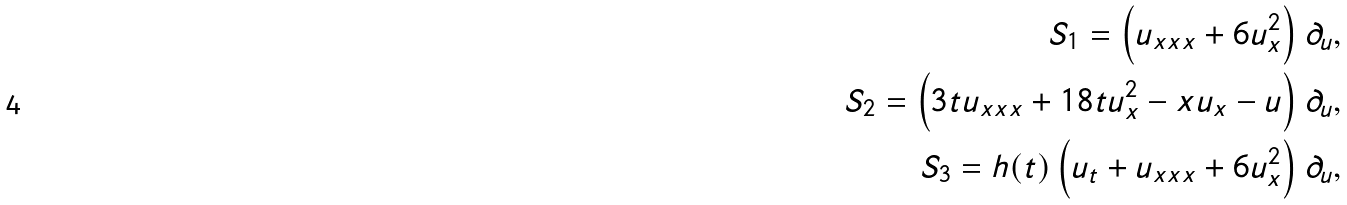Convert formula to latex. <formula><loc_0><loc_0><loc_500><loc_500>S _ { 1 } = \left ( u _ { x x x } + 6 u _ { x } ^ { 2 } \right ) \partial _ { u } , \\ S _ { 2 } = \left ( 3 t u _ { x x x } + 1 8 t u _ { x } ^ { 2 } - x u _ { x } - u \right ) \partial _ { u } , \\ S _ { 3 } = h ( t ) \left ( u _ { t } + u _ { x x x } + 6 u _ { x } ^ { 2 } \right ) \partial _ { u } ,</formula> 